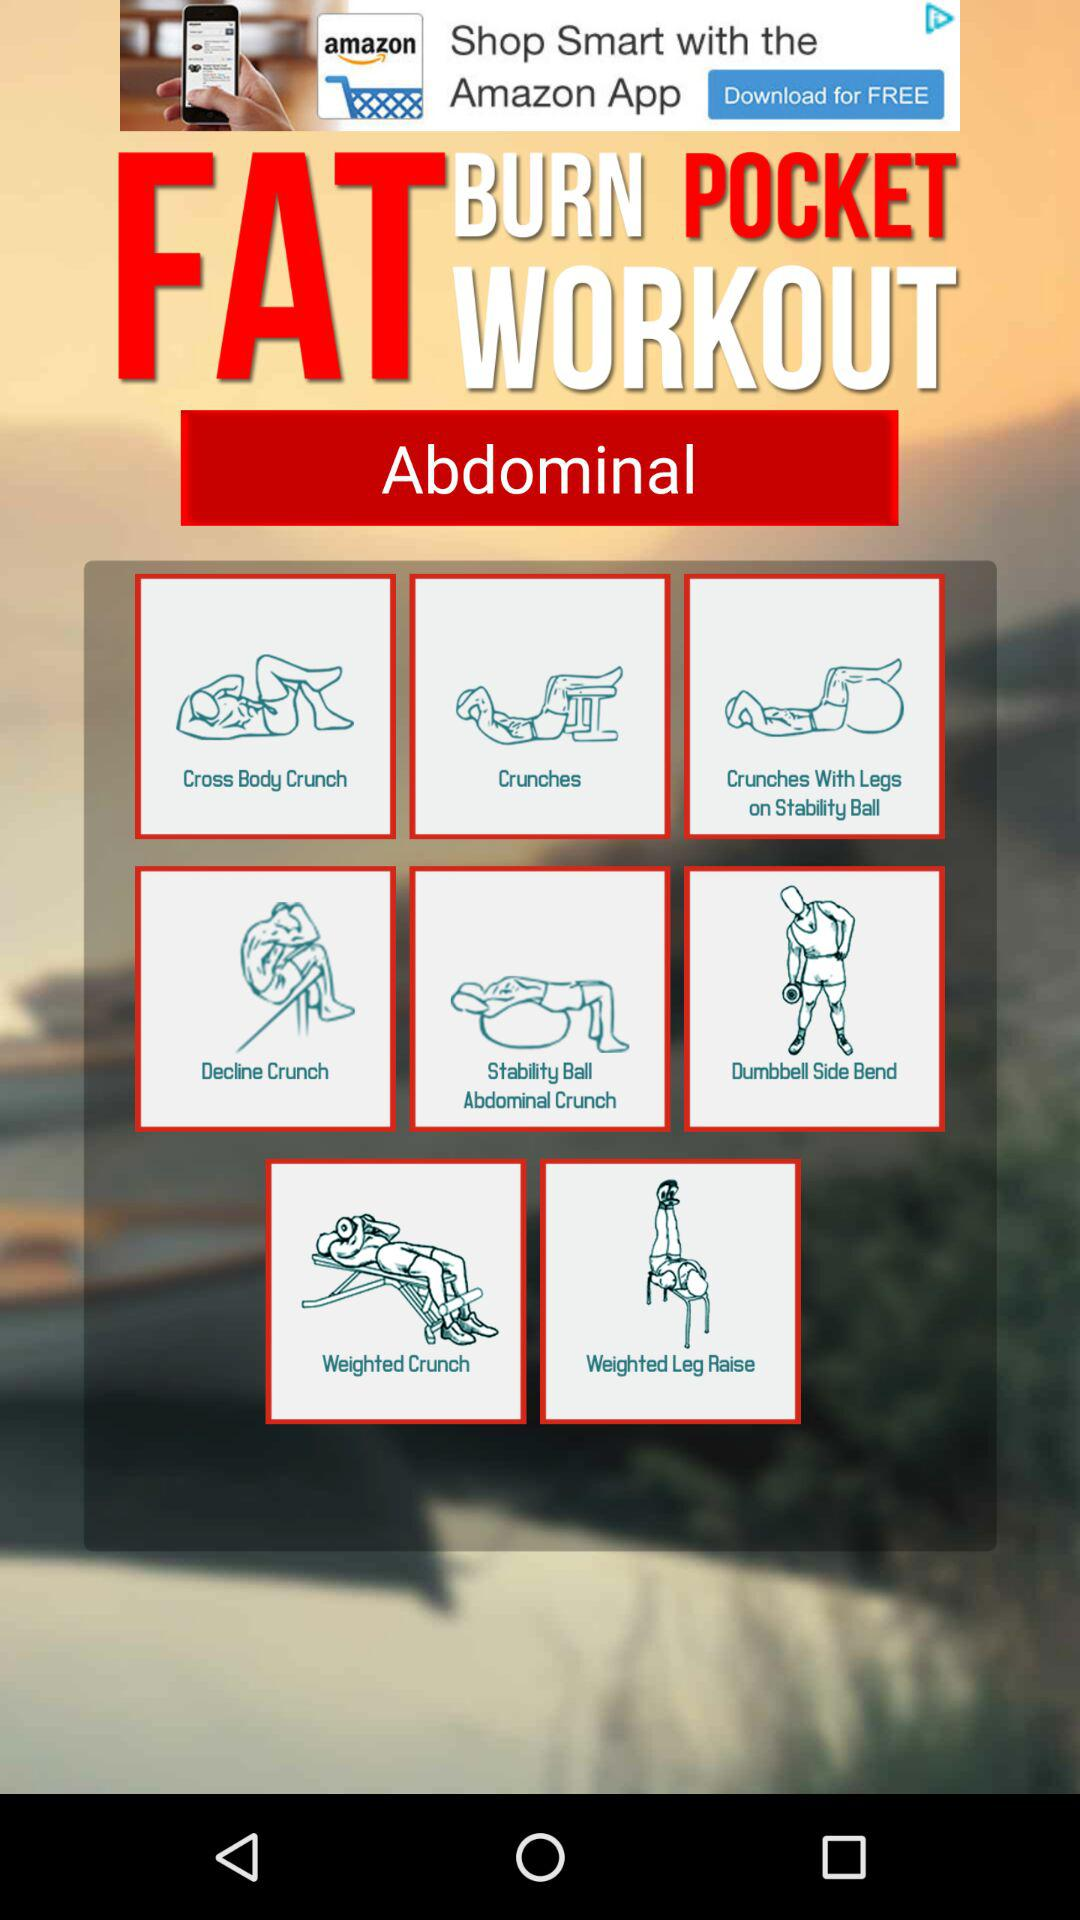What part of the body is the exercise for? The exercises are for the abdominals. 